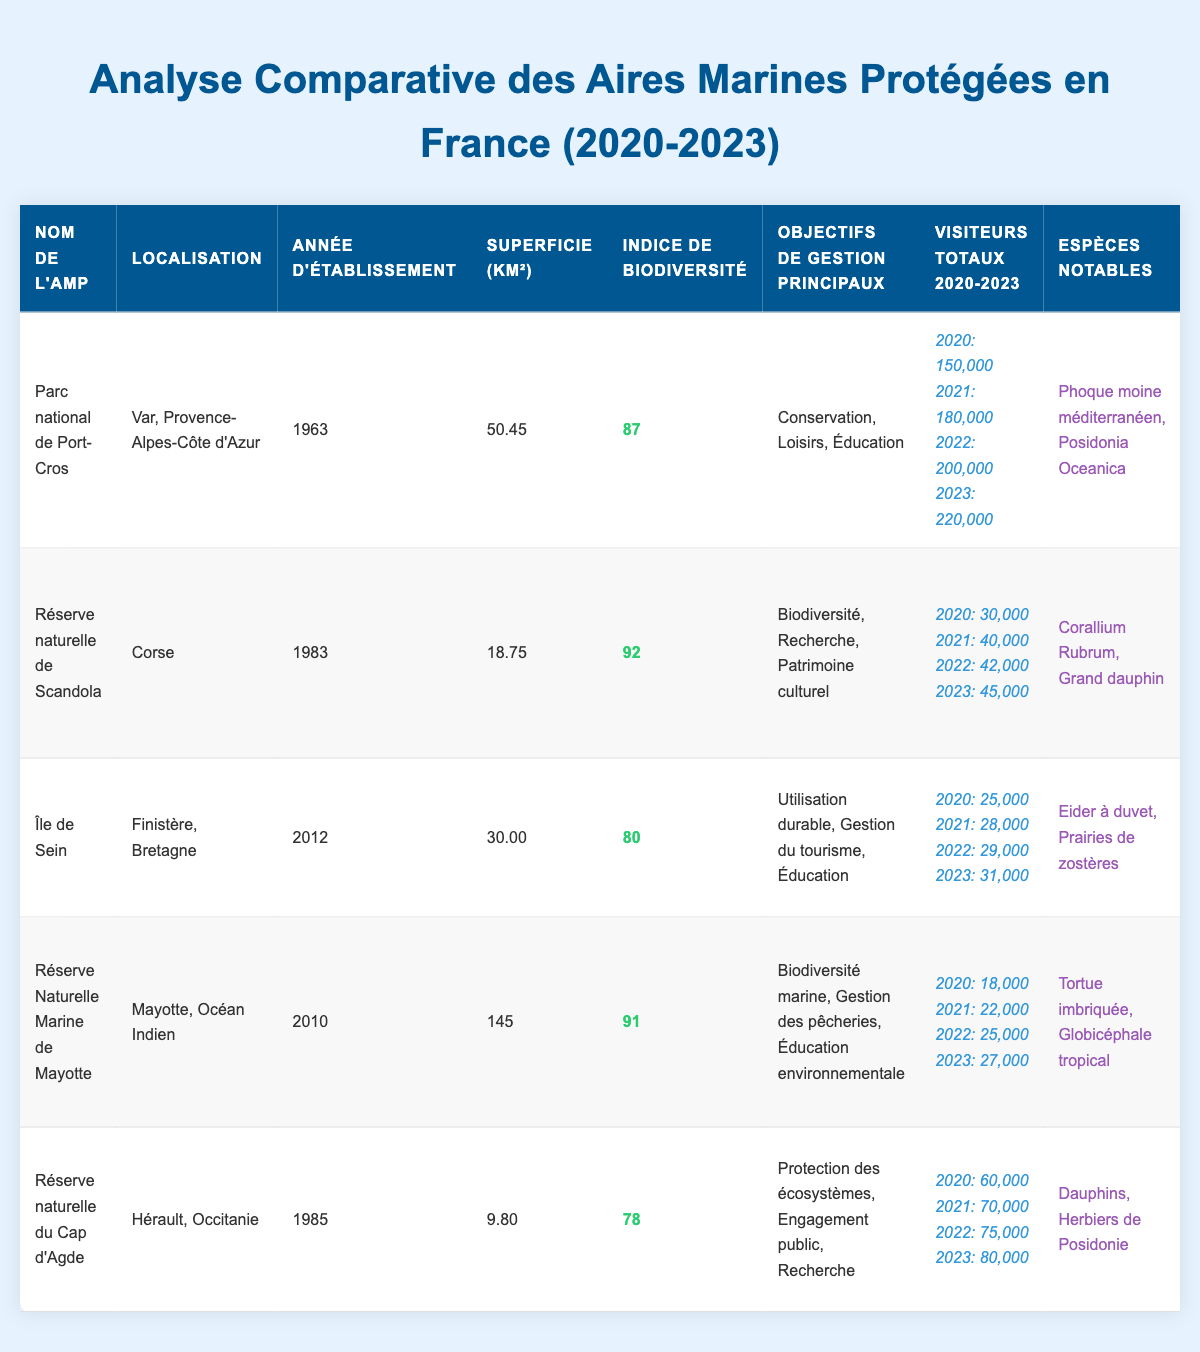What's the biodiversity index of Port-Cros National Park? The table indicates that the biodiversity index for Port-Cros National Park is listed directly under the "Indice de biodiversité" column next to its name. It shows a value of 87.
Answer: 87 Which MPA had the highest total visitors in 2023? By reviewing the "Visiteurs totaux 2020-2023" column for 2023, Port-Cros National Park has 220,000 visitors, which is more than any other MPA listed.
Answer: Port-Cros National Park How many total visitors did the Réserve Naturelle de Scandola have from 2020 to 2023? For the Réserve Naturelle de Scandola, total visitors over the years can be calculated by adding 30,000 (2020) + 40,000 (2021) + 42,000 (2022) + 45,000 (2023), which equals 157,000.
Answer: 157,000 Is the area of Ile de Sein larger than that of Cap d'Agde Nature Reserve? The area of Ile de Sein is 30 km² and the area of Cap d'Agde Nature Reserve is 9.80 km². Since 30 is greater than 9.80, the statement is true.
Answer: Yes What is the difference in biodiversity index between the Réserve Naturelle de Scandola and the Réserve Naturelle Marine de Mayotte? The biodiversity index for the Réserve Naturelle de Scandola is 92 and for the Réserve Naturelle Marine de Mayotte, it is 91. The difference is 92 - 91 = 1.
Answer: 1 What are the notable species found in the Cap d'Agde Nature Reserve? The table provides the notable species found in the Cap d'Agde Nature Reserve listed under the "Espèces notables" column. It indicates Dolphins and Posidonia beds as notable species.
Answer: Dolphins and Posidonia beds Which MPA showed the most significant increase in visitors from 2020 to 2023? By calculating the increase in visitors for each MPA from 2020 to 2023, Port-Cros National Park showed the largest increase: 220,000 - 150,000 = 70,000.
Answer: Port-Cros National Park Is it true that The Réserve Naturelle Marine de Mayotte has the largest area among the MPAs listed? The table lists the area of The Réserve Naturelle Marine de Mayotte as 145 km², which is larger than all other MPAs shown (50.45, 18.75, 30.00, and 9.80 km²). Therefore, the statement is true.
Answer: Yes What's the average number of visitors for Ile de Sein from 2020 to 2023? The average is calculated by adding the total visitors: 25,000 + 28,000 + 29,000 + 31,000 = 113,000. To find the average, divide by 4: 113,000 / 4 = 28,250.
Answer: 28,250 What management goals are listed for the Réserve naturelle de Scandola? The primary management goals for the Réserve naturelle de Scandola are specified in the "Objectifs de gestion principaux" column. They are Biodiversity, Research, and Cultural Heritage.
Answer: Biodiversity, Research, Cultural Heritage How does the total number of visitors to Cap d'Agde Nature Reserve in 2023 compare to that in 2020? The total visitors for Cap d'Agde Nature Reserve in 2023 is 80,000, compared to 60,000 in 2020. The difference is 80,000 - 60,000 = 20,000 more visitors in 2023.
Answer: 20,000 more visitors 